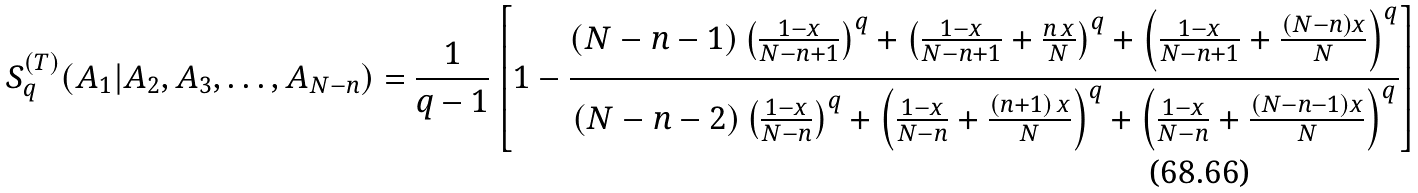Convert formula to latex. <formula><loc_0><loc_0><loc_500><loc_500>S ^ { ( T ) } _ { q } ( A _ { 1 } | A _ { 2 } , A _ { 3 } , \dots , A _ { N - n } ) = \frac { 1 } { q - 1 } \left [ 1 - \frac { ( N - n - 1 ) \left ( \frac { 1 - x } { N - n + 1 } \right ) ^ { q } + \left ( \frac { 1 - x } { N - n + 1 } + \frac { n \, x } { N } \right ) ^ { q } + \left ( \frac { 1 - x } { N - n + 1 } + \frac { ( N - n ) x } { N } \right ) ^ { q } } { ( N - n - 2 ) \left ( \frac { 1 - x } { N - n } \right ) ^ { q } + \left ( \frac { 1 - x } { N - n } + \frac { ( n + 1 ) \, x } { N } \right ) ^ { q } + \left ( \frac { 1 - x } { N - n } + \frac { ( N - n - 1 ) x } { N } \right ) ^ { q } } \right ]</formula> 